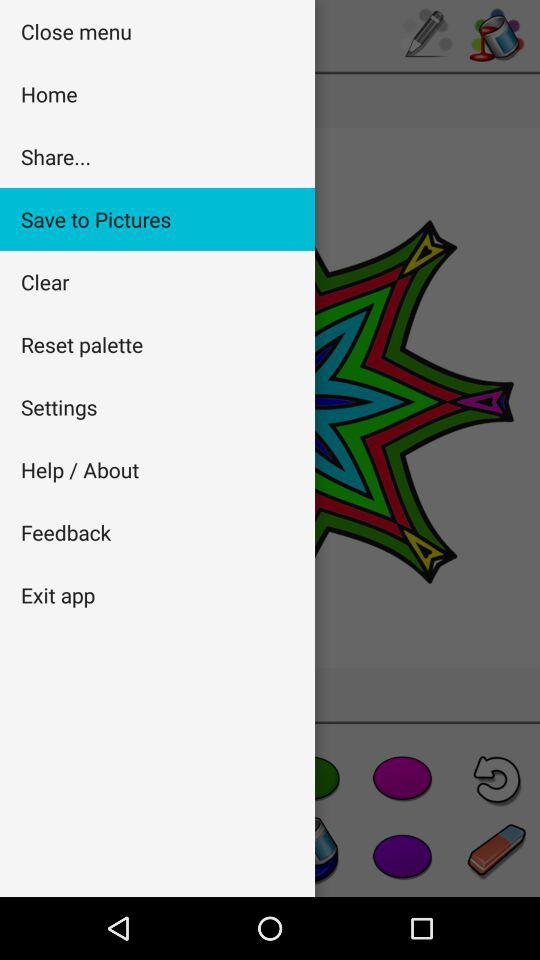What option is currently selected? The currently selected option is " Save to Pictures". 